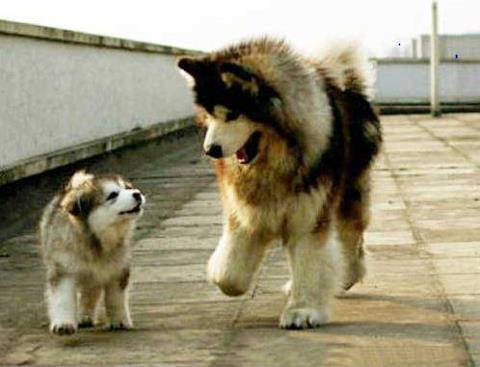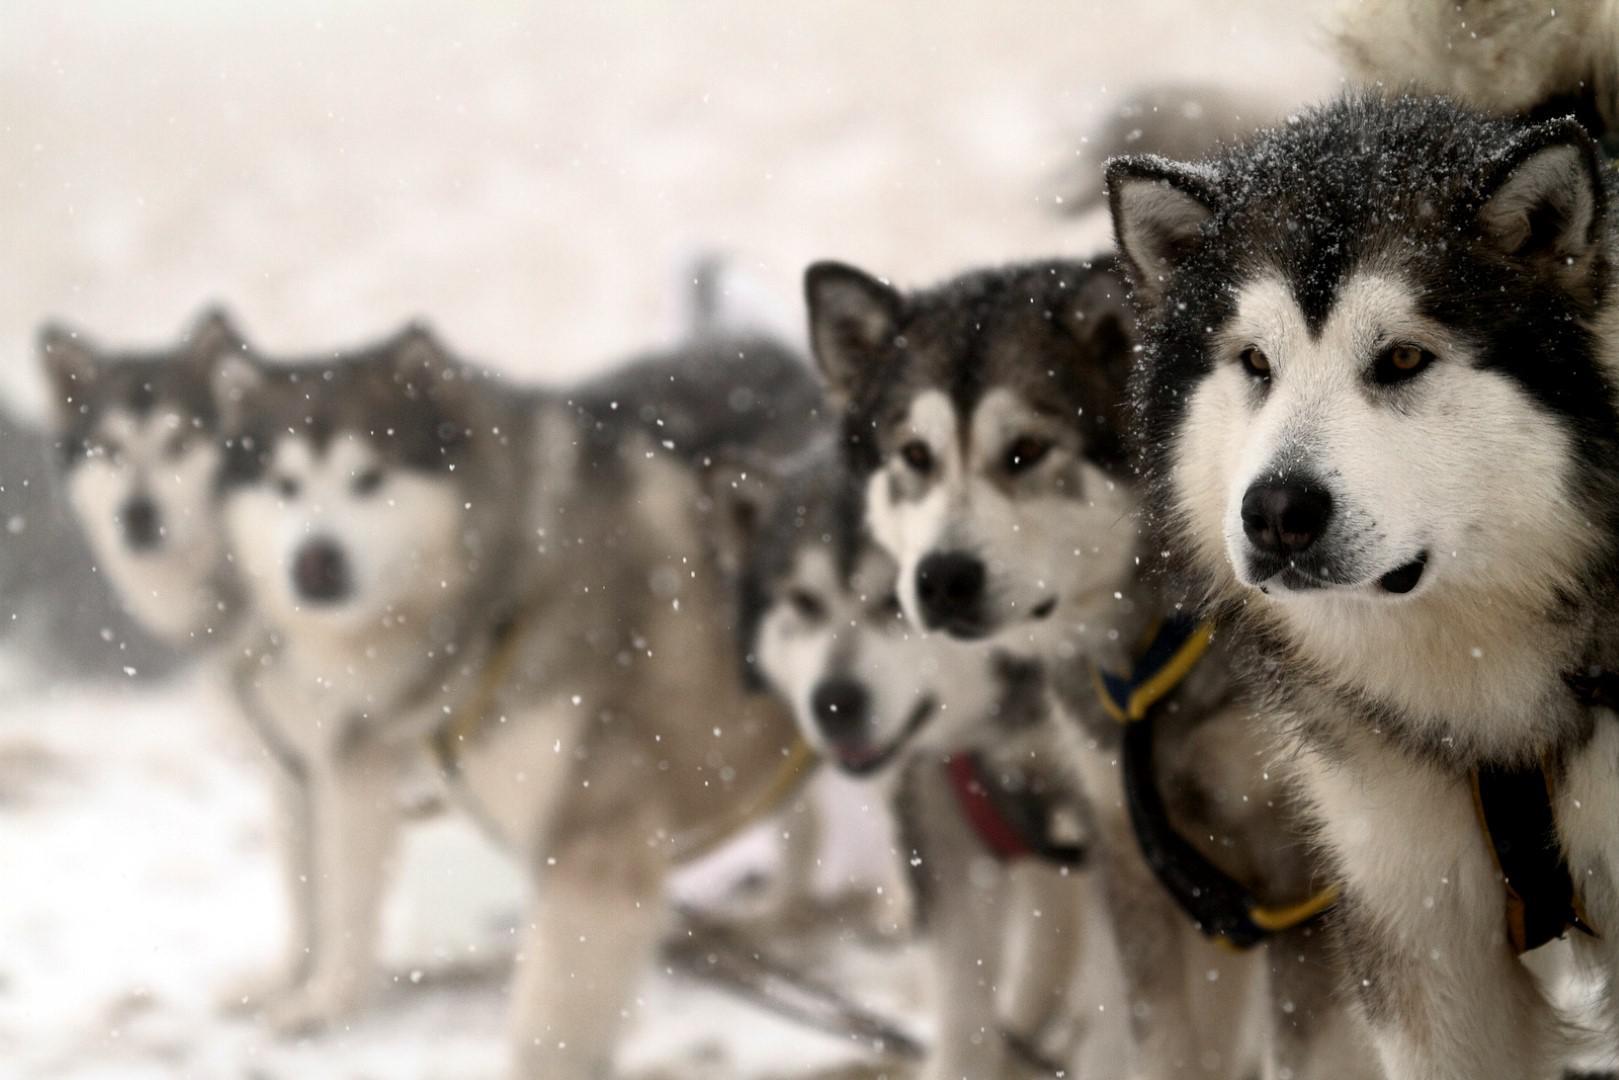The first image is the image on the left, the second image is the image on the right. Given the left and right images, does the statement "The left image includes a husky reclining with its head to the right, and the right image includes a husky reclining with front paws forward." hold true? Answer yes or no. No. 